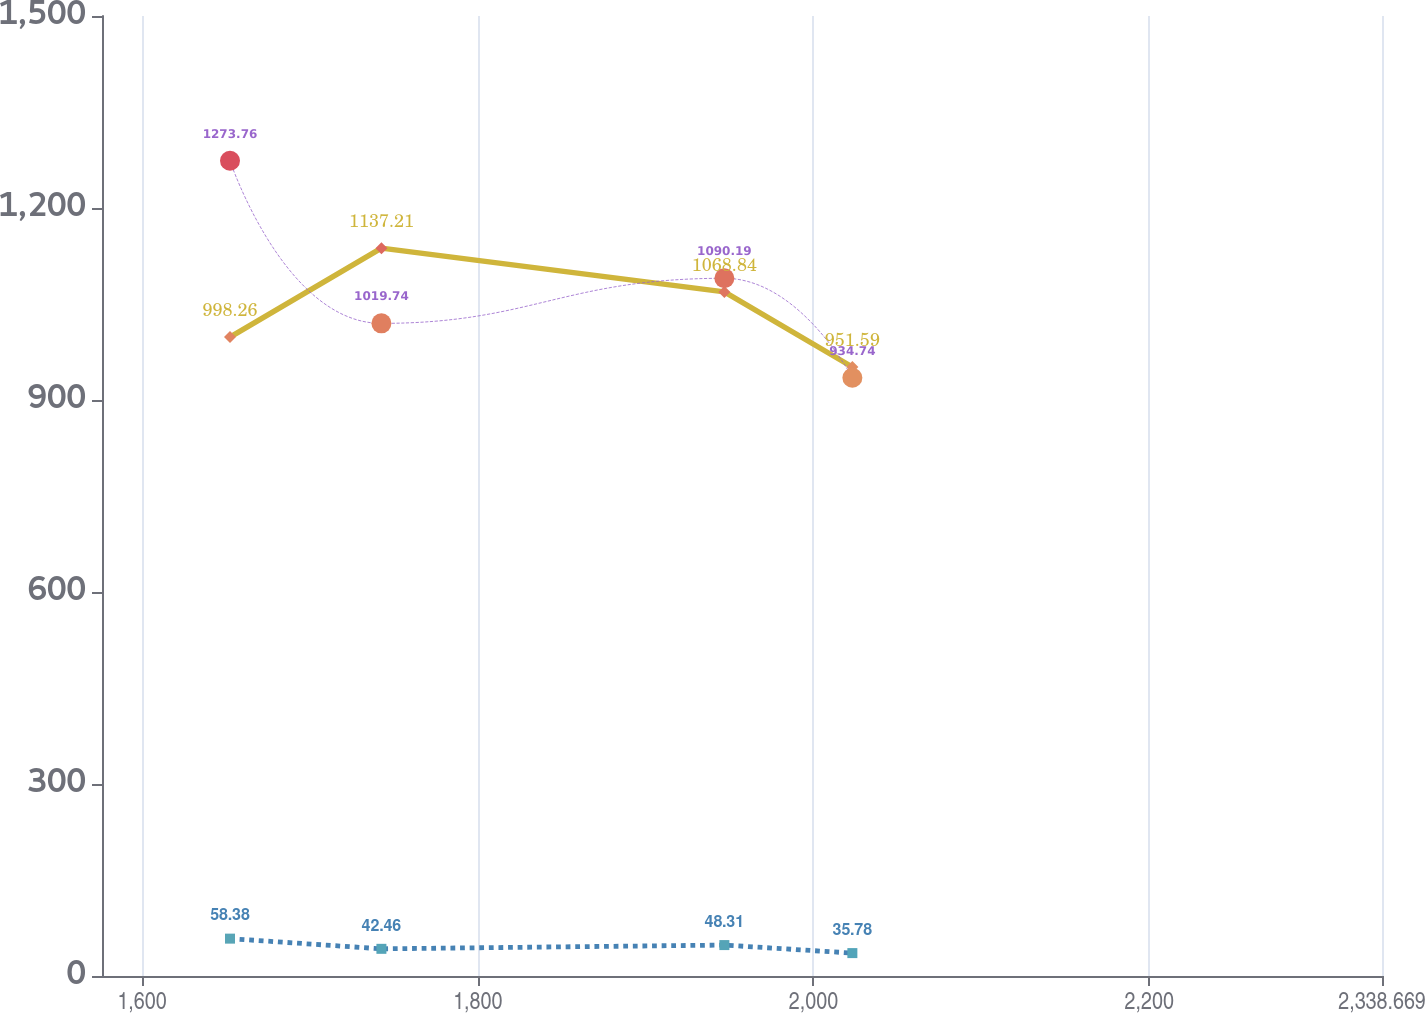Convert chart to OTSL. <chart><loc_0><loc_0><loc_500><loc_500><line_chart><ecel><fcel>Restaurant<fcel>Other<fcel>Total<nl><fcel>1652.41<fcel>998.26<fcel>58.38<fcel>1273.76<nl><fcel>1742.61<fcel>1137.21<fcel>42.46<fcel>1019.74<nl><fcel>1946.91<fcel>1068.84<fcel>48.31<fcel>1090.19<nl><fcel>2023.16<fcel>951.59<fcel>35.78<fcel>934.74<nl><fcel>2414.92<fcel>714.34<fcel>26.6<fcel>897.07<nl></chart> 